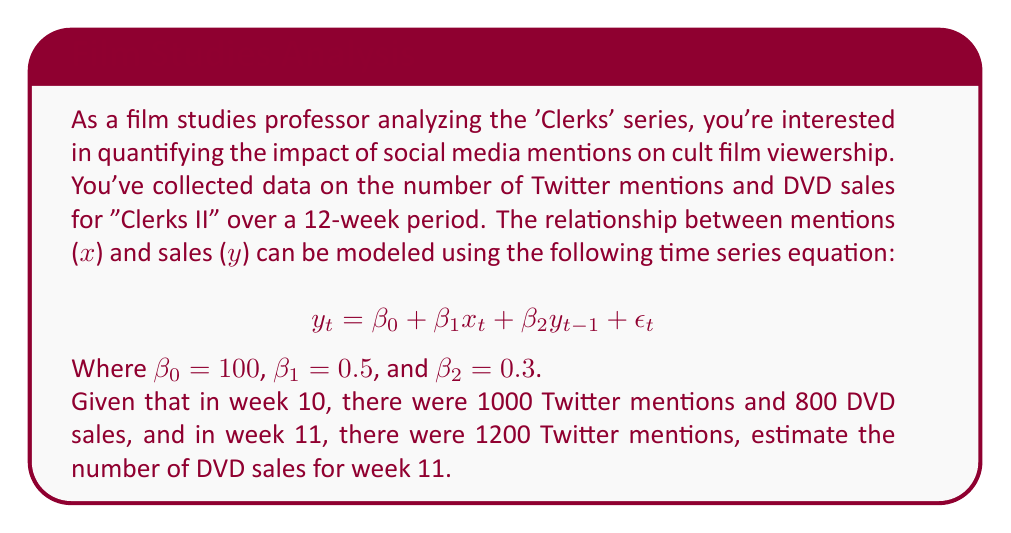Can you solve this math problem? Let's approach this step-by-step:

1) We're given the time series equation:
   $$y_t = \beta_0 + \beta_1x_t + \beta_2y_{t-1} + \epsilon_t$$

2) We know the values of the coefficients:
   $\beta_0 = 100$, $\beta_1 = 0.5$, and $\beta_2 = 0.3$

3) We're also given:
   - Week 10: $x_{10} = 1000$, $y_{10} = 800$
   - Week 11: $x_{11} = 1200$

4) We need to find $y_{11}$. Let's substitute the known values into the equation:

   $$y_{11} = 100 + 0.5x_{11} + 0.3y_{10} + \epsilon_{11}$$

5) We'll assume $\epsilon_{11} = 0$ for this estimation.

6) Now, let's plug in the known values:

   $$y_{11} = 100 + 0.5(1200) + 0.3(800)$$

7) Let's calculate:
   $$y_{11} = 100 + 600 + 240$$
   $$y_{11} = 940$$

Therefore, we estimate 940 DVD sales for week 11.
Answer: 940 DVD sales 